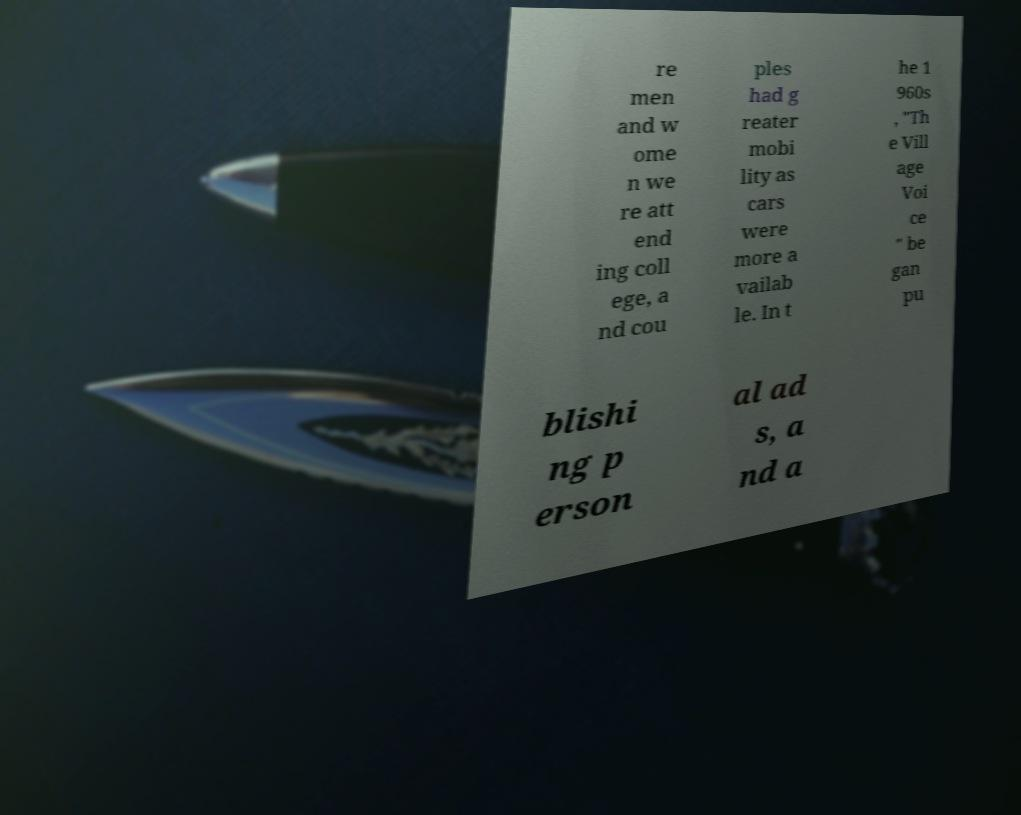I need the written content from this picture converted into text. Can you do that? re men and w ome n we re att end ing coll ege, a nd cou ples had g reater mobi lity as cars were more a vailab le. In t he 1 960s , "Th e Vill age Voi ce " be gan pu blishi ng p erson al ad s, a nd a 